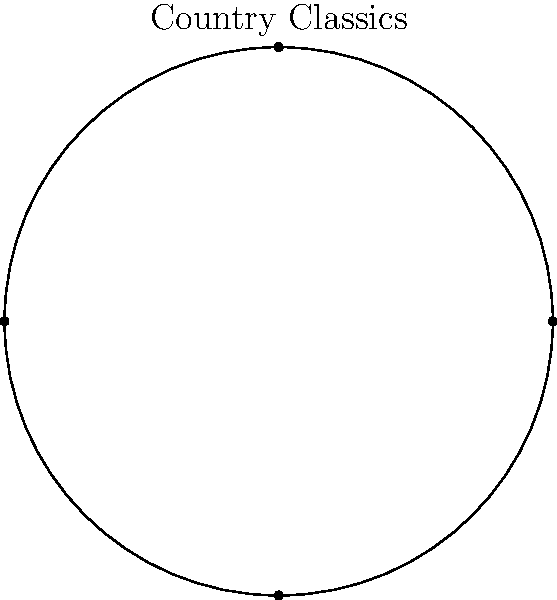As a folk singer-songwriter with a deep appreciation for country music history, you've come across a unique vinyl record of rare country classics. The record label wants to create a special edition with a distorted shape. If the original circular vinyl record has a radius of 6 inches and undergoes a horizontal shear transformation with a shear factor of 1.5, what is the new horizontal width of the distorted vinyl record? To solve this problem, let's follow these steps:

1. Understand the original dimensions:
   - The vinyl record is initially circular with a radius of 6 inches.
   - The diameter (width) of the original record is $2r = 2 * 6 = 12$ inches.

2. Understand the shear transformation:
   - A horizontal shear with factor 1.5 means that for every unit moved vertically, there's a 1.5 unit horizontal displacement.
   - The shear matrix for this transformation is $\begin{bmatrix} 1 & 1.5 \\ 0 & 1 \end{bmatrix}$.

3. Apply the shear transformation:
   - The leftmost point of the record moves to the left: $(-6, 0) \rightarrow (-6, 0)$
   - The rightmost point of the record moves to the right: $(6, 0) \rightarrow (6, 0)$
   - The top point of the record moves right: $(0, 6) \rightarrow (9, 6)$
   - The bottom point of the record moves left: $(0, -6) \rightarrow (-9, -6)$

4. Calculate the new horizontal width:
   - The new width is the distance between the leftmost and rightmost points after transformation.
   - Leftmost point: $x = -9$
   - Rightmost point: $x = 9$
   - New width $= 9 - (-9) = 18$ inches

Thus, the new horizontal width of the distorted vinyl record is 18 inches.
Answer: 18 inches 